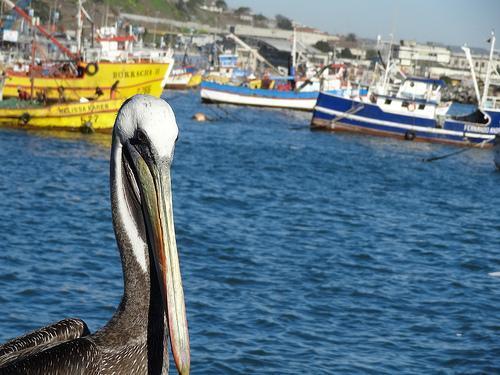How many birds are there?
Give a very brief answer. 1. 